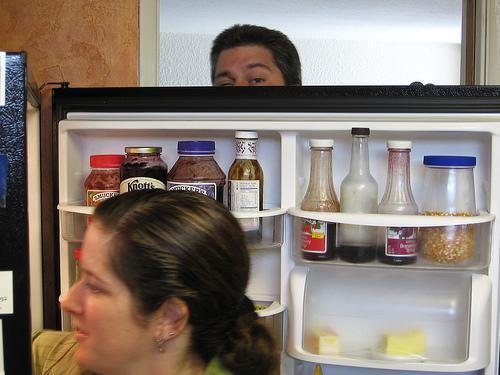How many people are shown?
Give a very brief answer. 2. How many jars are across the top shelf of the fridge door?
Give a very brief answer. 8. 